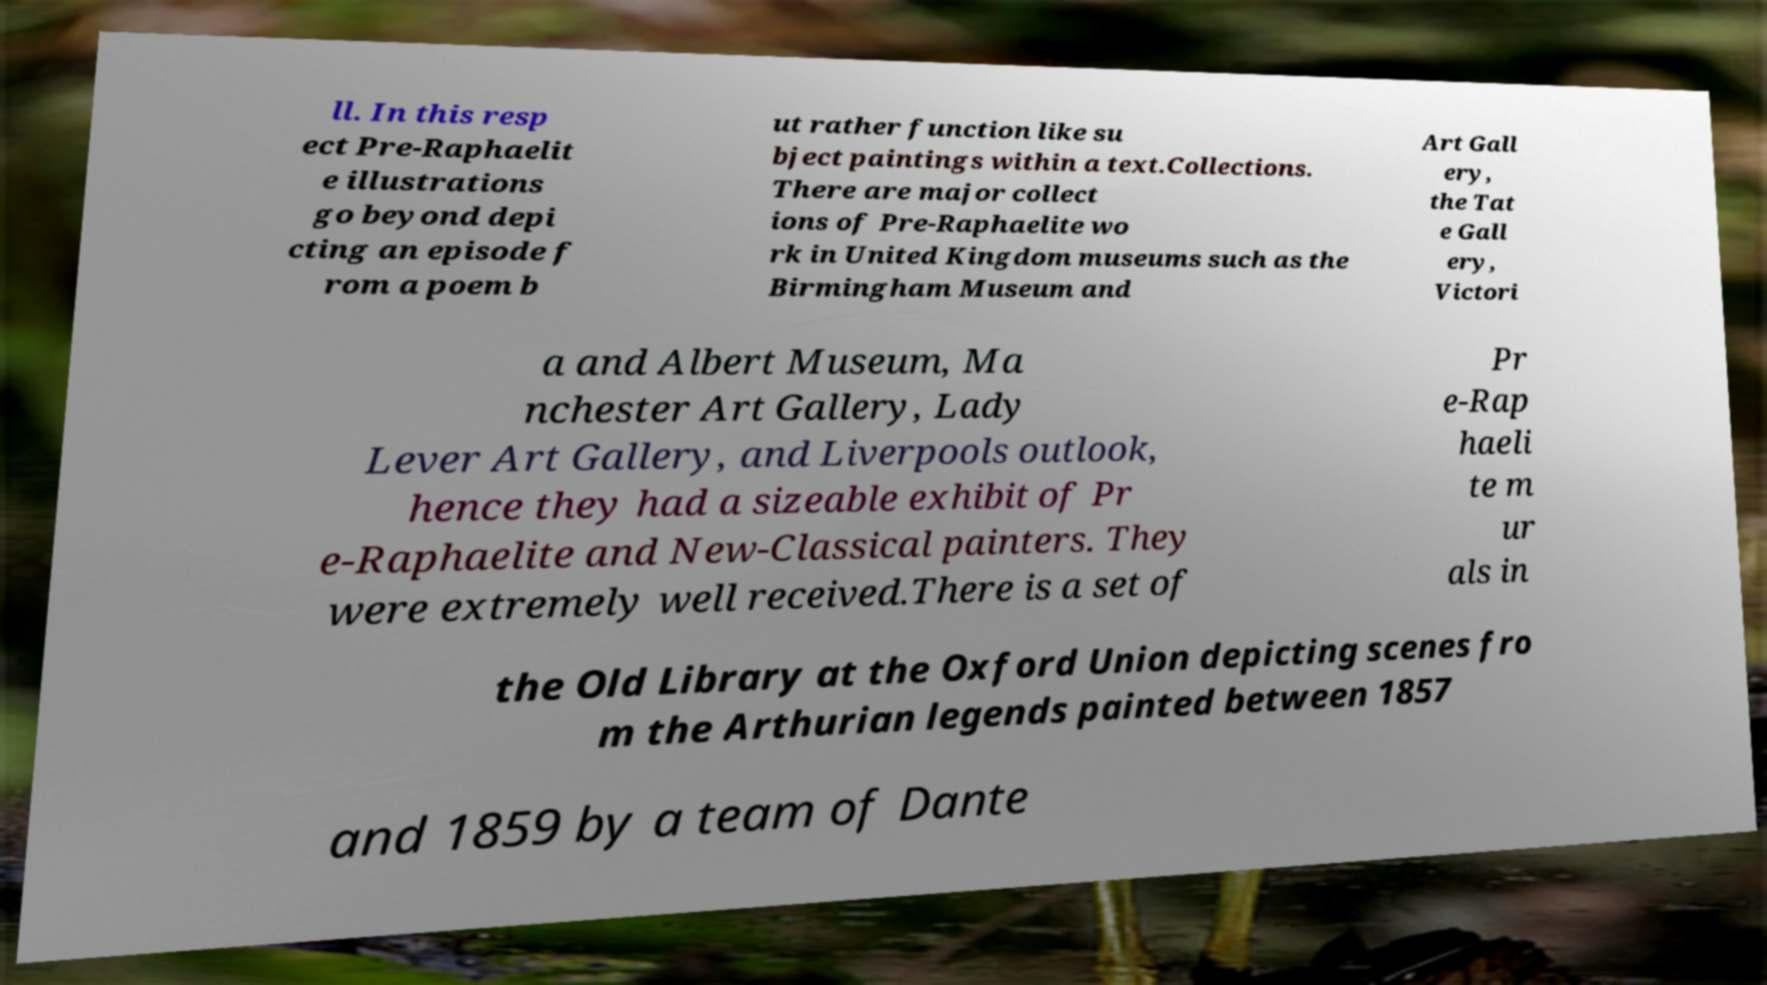Can you accurately transcribe the text from the provided image for me? ll. In this resp ect Pre-Raphaelit e illustrations go beyond depi cting an episode f rom a poem b ut rather function like su bject paintings within a text.Collections. There are major collect ions of Pre-Raphaelite wo rk in United Kingdom museums such as the Birmingham Museum and Art Gall ery, the Tat e Gall ery, Victori a and Albert Museum, Ma nchester Art Gallery, Lady Lever Art Gallery, and Liverpools outlook, hence they had a sizeable exhibit of Pr e-Raphaelite and New-Classical painters. They were extremely well received.There is a set of Pr e-Rap haeli te m ur als in the Old Library at the Oxford Union depicting scenes fro m the Arthurian legends painted between 1857 and 1859 by a team of Dante 